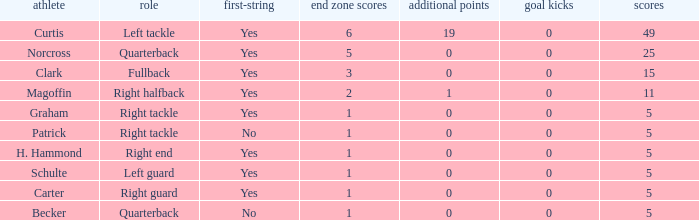Name the least touchdowns for 11 points 2.0. Give me the full table as a dictionary. {'header': ['athlete', 'role', 'first-string', 'end zone scores', 'additional points', 'goal kicks', 'scores'], 'rows': [['Curtis', 'Left tackle', 'Yes', '6', '19', '0', '49'], ['Norcross', 'Quarterback', 'Yes', '5', '0', '0', '25'], ['Clark', 'Fullback', 'Yes', '3', '0', '0', '15'], ['Magoffin', 'Right halfback', 'Yes', '2', '1', '0', '11'], ['Graham', 'Right tackle', 'Yes', '1', '0', '0', '5'], ['Patrick', 'Right tackle', 'No', '1', '0', '0', '5'], ['H. Hammond', 'Right end', 'Yes', '1', '0', '0', '5'], ['Schulte', 'Left guard', 'Yes', '1', '0', '0', '5'], ['Carter', 'Right guard', 'Yes', '1', '0', '0', '5'], ['Becker', 'Quarterback', 'No', '1', '0', '0', '5']]} 